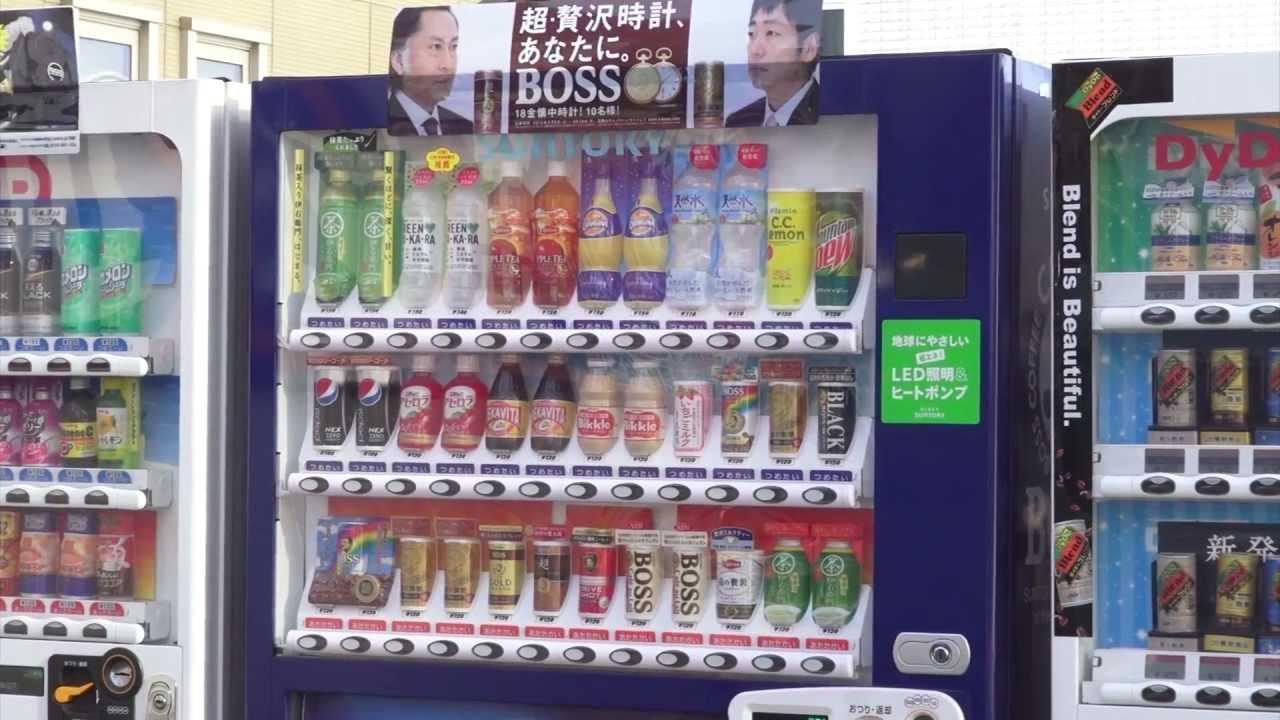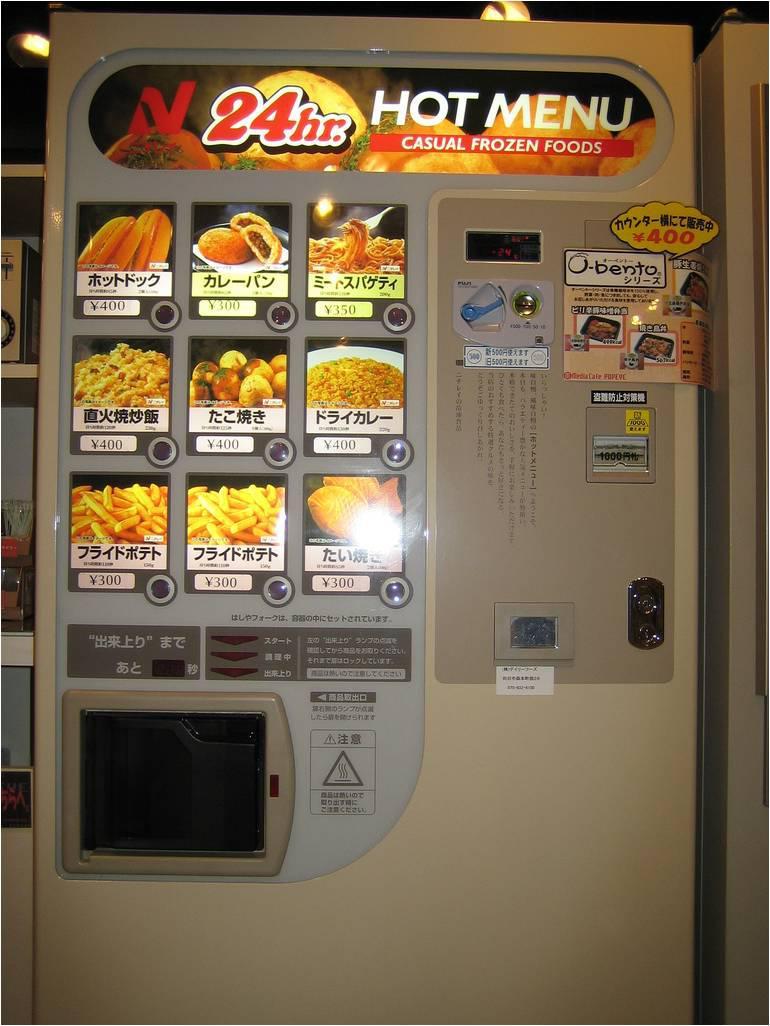The first image is the image on the left, the second image is the image on the right. Considering the images on both sides, is "In a row of at least five vending machines, one machine is gray." valid? Answer yes or no. No. The first image is the image on the left, the second image is the image on the right. Assess this claim about the two images: "One of the images shows a white vending machine that offers plates of food instead of beverages.". Correct or not? Answer yes or no. Yes. 